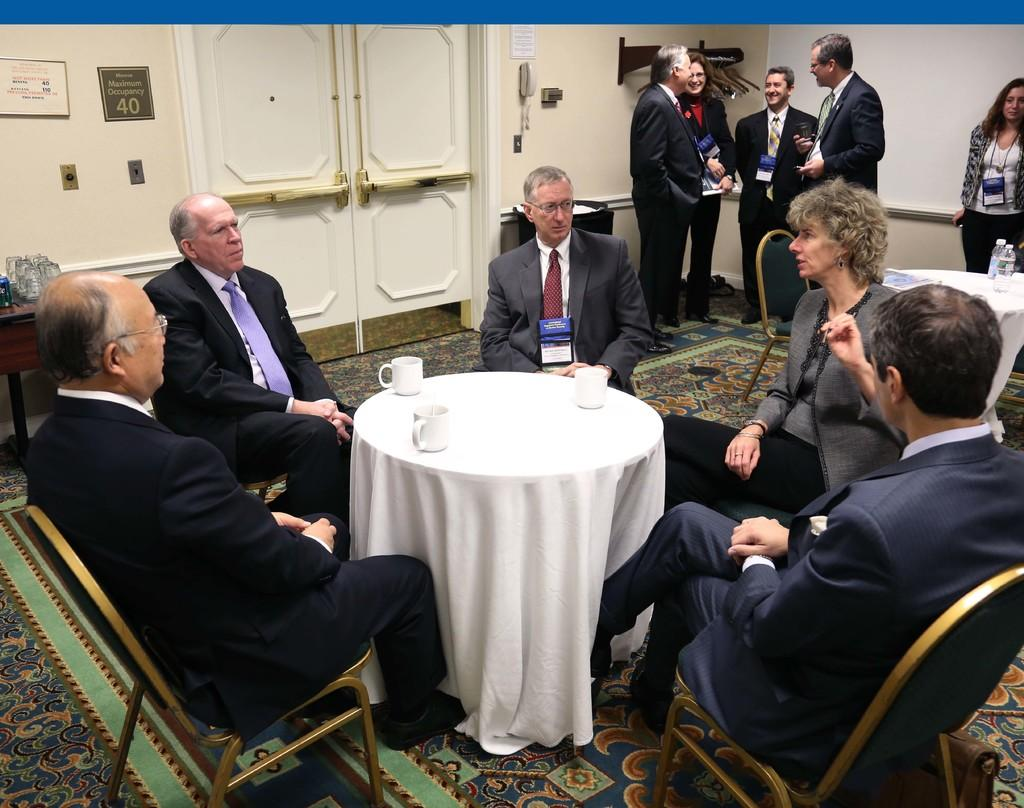What is the main subject of the image? The main subject of the image is a group of people. What are some of the people in the image doing? Some people are sitting in chairs, while others are standing in the background. What is present on the table in the image? There is a cup on the table. Can you describe the table in the image? The table is a piece of furniture where the cup is placed. What type of pipe can be seen in the image? There is no pipe present in the image. How many children are visible in the image? The image does not depict any children; it features a group of people, but their ages are not specified. 